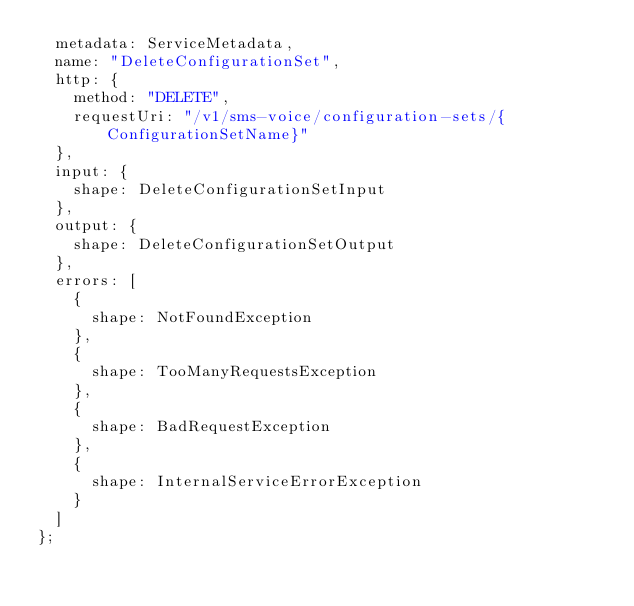<code> <loc_0><loc_0><loc_500><loc_500><_TypeScript_>  metadata: ServiceMetadata,
  name: "DeleteConfigurationSet",
  http: {
    method: "DELETE",
    requestUri: "/v1/sms-voice/configuration-sets/{ConfigurationSetName}"
  },
  input: {
    shape: DeleteConfigurationSetInput
  },
  output: {
    shape: DeleteConfigurationSetOutput
  },
  errors: [
    {
      shape: NotFoundException
    },
    {
      shape: TooManyRequestsException
    },
    {
      shape: BadRequestException
    },
    {
      shape: InternalServiceErrorException
    }
  ]
};
</code> 